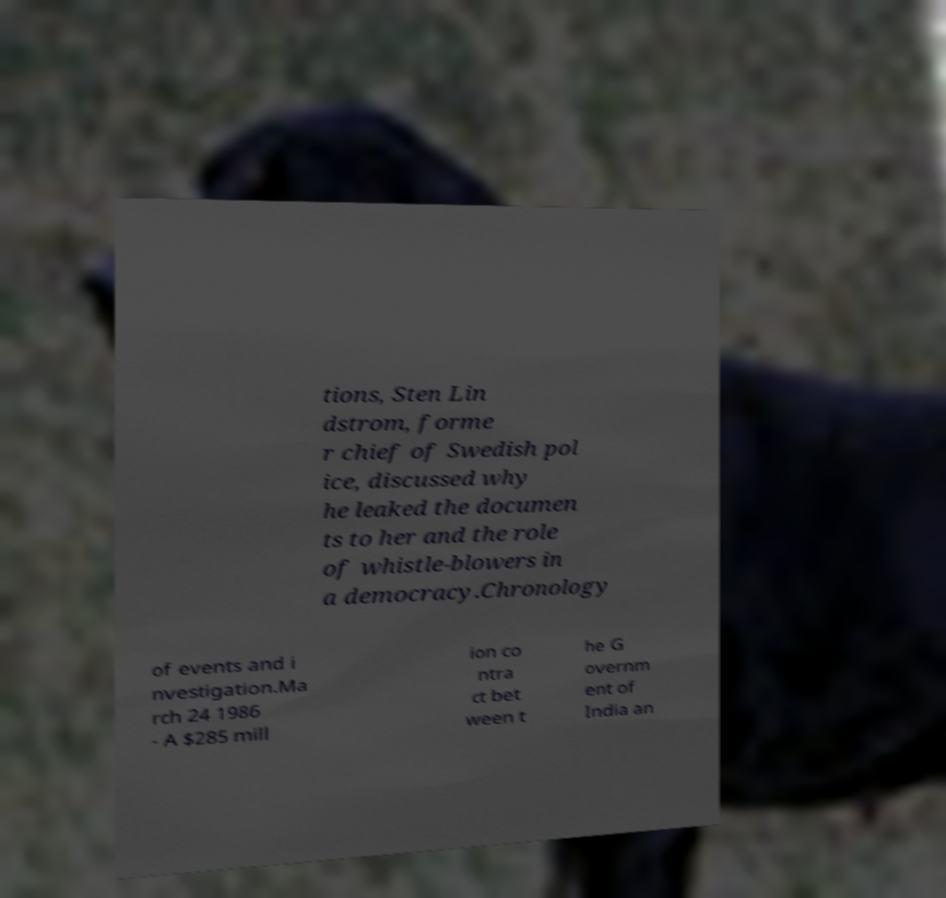Please identify and transcribe the text found in this image. tions, Sten Lin dstrom, forme r chief of Swedish pol ice, discussed why he leaked the documen ts to her and the role of whistle-blowers in a democracy.Chronology of events and i nvestigation.Ma rch 24 1986 - A $285 mill ion co ntra ct bet ween t he G overnm ent of India an 